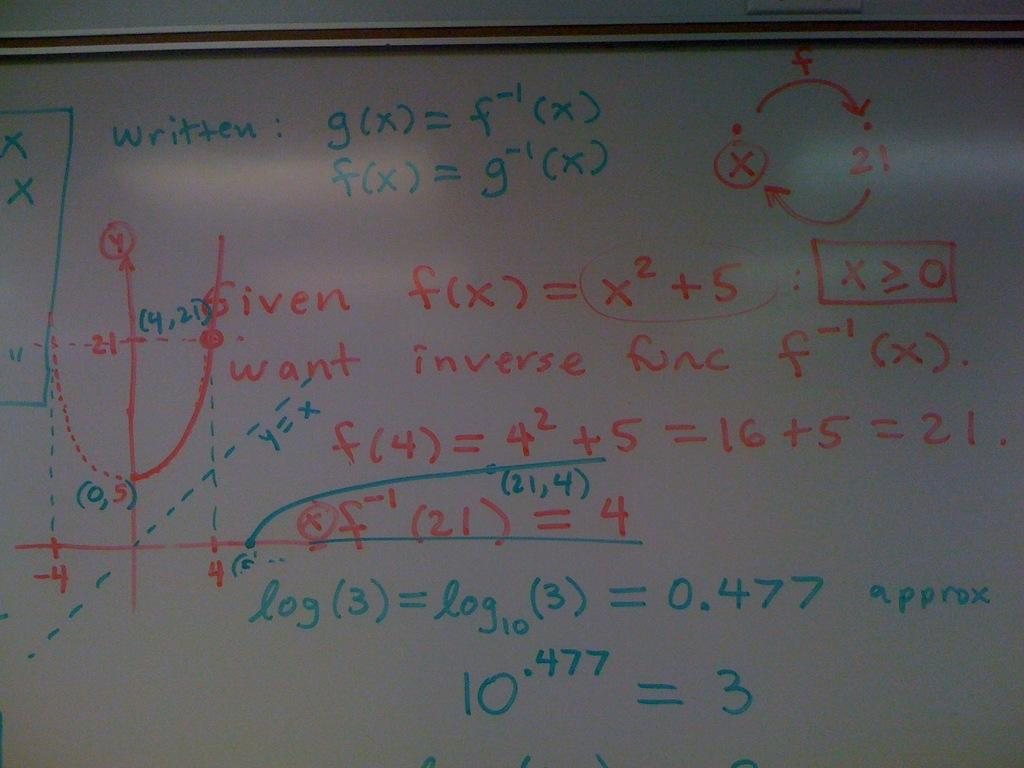<image>
Give a short and clear explanation of the subsequent image. math is on the board with the number 3 on it 